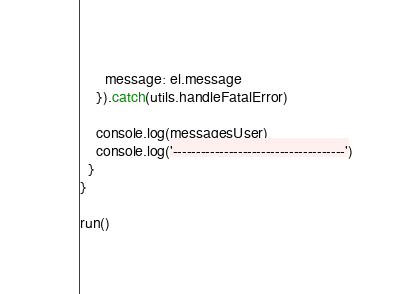<code> <loc_0><loc_0><loc_500><loc_500><_JavaScript_>      message: el.message
    }).catch(utils.handleFatalError)

    console.log(messagesUser)
    console.log('-------------------------------------')
  }
}

run()
</code> 